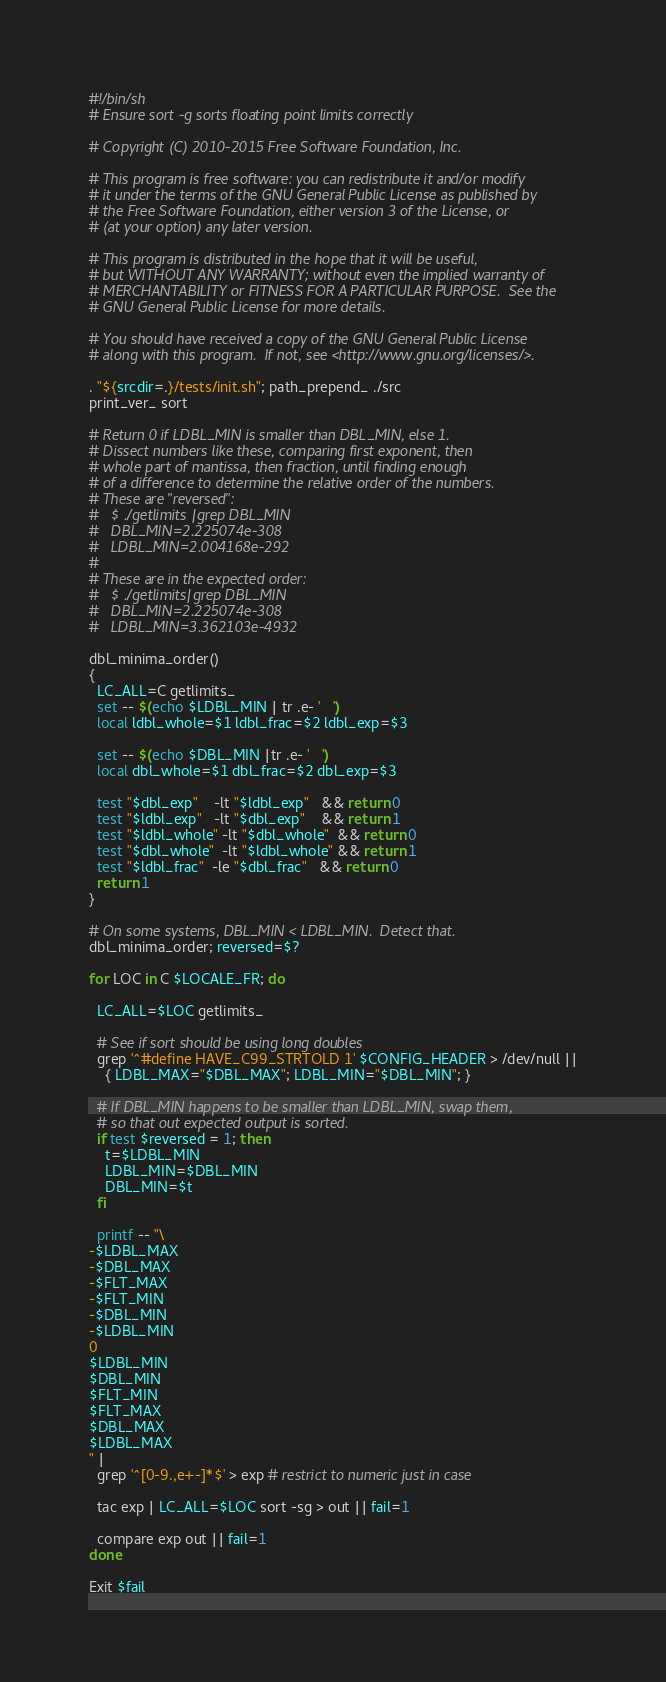Convert code to text. <code><loc_0><loc_0><loc_500><loc_500><_Bash_>#!/bin/sh
# Ensure sort -g sorts floating point limits correctly

# Copyright (C) 2010-2015 Free Software Foundation, Inc.

# This program is free software: you can redistribute it and/or modify
# it under the terms of the GNU General Public License as published by
# the Free Software Foundation, either version 3 of the License, or
# (at your option) any later version.

# This program is distributed in the hope that it will be useful,
# but WITHOUT ANY WARRANTY; without even the implied warranty of
# MERCHANTABILITY or FITNESS FOR A PARTICULAR PURPOSE.  See the
# GNU General Public License for more details.

# You should have received a copy of the GNU General Public License
# along with this program.  If not, see <http://www.gnu.org/licenses/>.

. "${srcdir=.}/tests/init.sh"; path_prepend_ ./src
print_ver_ sort

# Return 0 if LDBL_MIN is smaller than DBL_MIN, else 1.
# Dissect numbers like these, comparing first exponent, then
# whole part of mantissa, then fraction, until finding enough
# of a difference to determine the relative order of the numbers.
# These are "reversed":
#   $ ./getlimits |grep DBL_MIN
#   DBL_MIN=2.225074e-308
#   LDBL_MIN=2.004168e-292
#
# These are in the expected order:
#   $ ./getlimits|grep DBL_MIN
#   DBL_MIN=2.225074e-308
#   LDBL_MIN=3.362103e-4932

dbl_minima_order()
{
  LC_ALL=C getlimits_
  set -- $(echo $LDBL_MIN | tr .e- '   ')
  local ldbl_whole=$1 ldbl_frac=$2 ldbl_exp=$3

  set -- $(echo $DBL_MIN |tr .e- '   ')
  local dbl_whole=$1 dbl_frac=$2 dbl_exp=$3

  test "$dbl_exp"    -lt "$ldbl_exp"   && return 0
  test "$ldbl_exp"   -lt "$dbl_exp"    && return 1
  test "$ldbl_whole" -lt "$dbl_whole"  && return 0
  test "$dbl_whole"  -lt "$ldbl_whole" && return 1
  test "$ldbl_frac"  -le "$dbl_frac"   && return 0
  return 1
}

# On some systems, DBL_MIN < LDBL_MIN.  Detect that.
dbl_minima_order; reversed=$?

for LOC in C $LOCALE_FR; do

  LC_ALL=$LOC getlimits_

  # See if sort should be using long doubles
  grep '^#define HAVE_C99_STRTOLD 1' $CONFIG_HEADER > /dev/null ||
    { LDBL_MAX="$DBL_MAX"; LDBL_MIN="$DBL_MIN"; }

  # If DBL_MIN happens to be smaller than LDBL_MIN, swap them,
  # so that out expected output is sorted.
  if test $reversed = 1; then
    t=$LDBL_MIN
    LDBL_MIN=$DBL_MIN
    DBL_MIN=$t
  fi

  printf -- "\
-$LDBL_MAX
-$DBL_MAX
-$FLT_MAX
-$FLT_MIN
-$DBL_MIN
-$LDBL_MIN
0
$LDBL_MIN
$DBL_MIN
$FLT_MIN
$FLT_MAX
$DBL_MAX
$LDBL_MAX
" |
  grep '^[0-9.,e+-]*$' > exp # restrict to numeric just in case

  tac exp | LC_ALL=$LOC sort -sg > out || fail=1

  compare exp out || fail=1
done

Exit $fail
</code> 